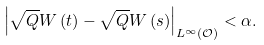<formula> <loc_0><loc_0><loc_500><loc_500>\left | \sqrt { Q } W \left ( t \right ) - \sqrt { Q } W \left ( s \right ) \right | _ { L ^ { \infty } \left ( \mathcal { O } \right ) } < \alpha .</formula> 